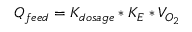Convert formula to latex. <formula><loc_0><loc_0><loc_500><loc_500>Q _ { f e e d } = K _ { d o s a g e } * K _ { E } * V _ { O _ { 2 } }</formula> 